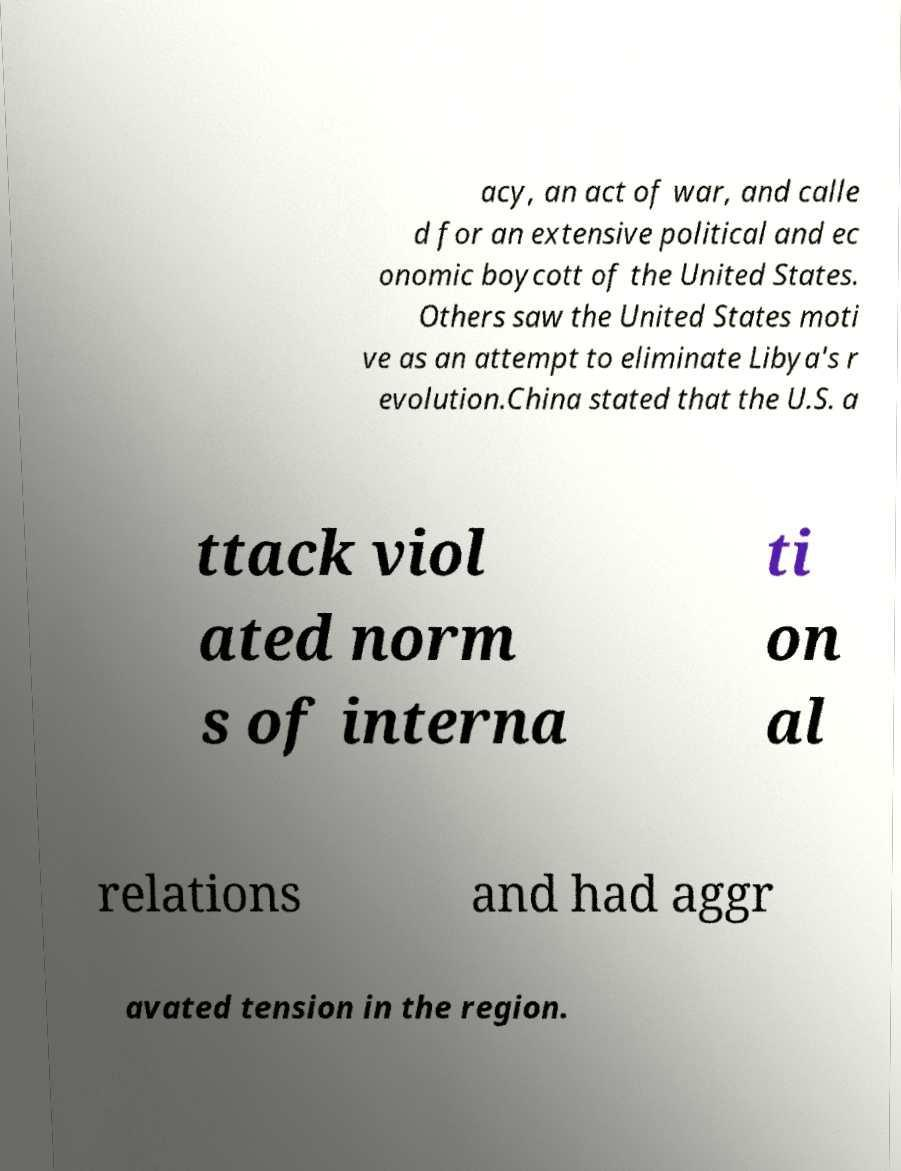Could you assist in decoding the text presented in this image and type it out clearly? acy, an act of war, and calle d for an extensive political and ec onomic boycott of the United States. Others saw the United States moti ve as an attempt to eliminate Libya's r evolution.China stated that the U.S. a ttack viol ated norm s of interna ti on al relations and had aggr avated tension in the region. 